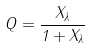<formula> <loc_0><loc_0><loc_500><loc_500>Q = \frac { X _ { \lambda } } { 1 + X _ { \lambda } }</formula> 